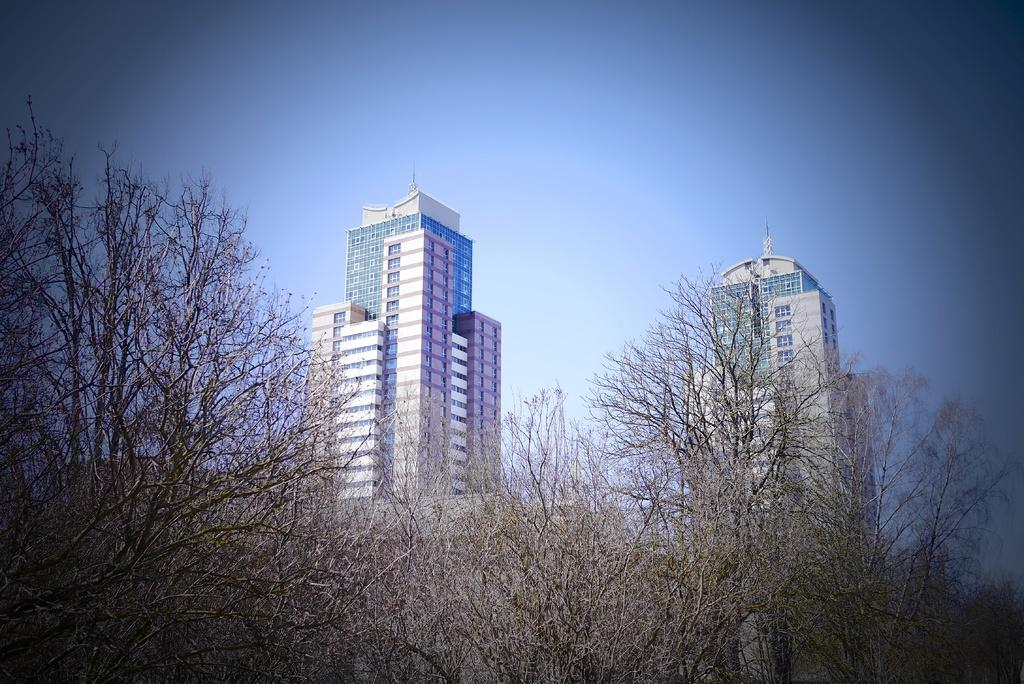What type of vegetation can be seen in the image? There are dried trees in the image. What structures are present in the image? There are two tower buildings in the image. What features do the tower buildings have? The tower buildings have windows and glasses. What is the color of the sky in the image? The sky is blue in color in the image. What type of action is the cake performing in the image? There are no cakes present in the image, so no action involving a cake can be observed. 